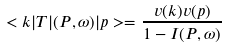Convert formula to latex. <formula><loc_0><loc_0><loc_500><loc_500>< k | T | ( P , \omega ) | p > = \frac { v ( k ) v ( p ) } { 1 - I ( P , \omega ) }</formula> 